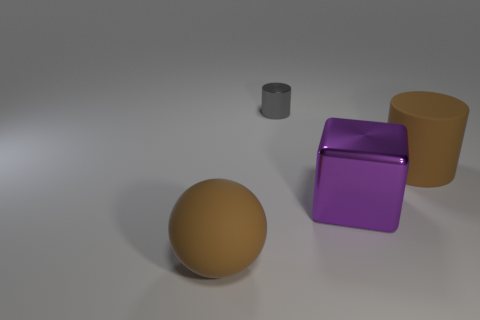Are there any large objects that have the same color as the large ball?
Make the answer very short. Yes. How many blocks are either gray metallic objects or big matte objects?
Give a very brief answer. 0. Is there a brown matte thing of the same shape as the tiny shiny object?
Make the answer very short. Yes. What number of other objects are the same color as the tiny thing?
Give a very brief answer. 0. Are there fewer gray metallic objects that are left of the brown matte sphere than red metal cylinders?
Offer a terse response. No. What number of tiny brown metallic objects are there?
Give a very brief answer. 0. How many cylinders have the same material as the large brown sphere?
Your answer should be very brief. 1. What number of objects are rubber objects that are behind the large rubber sphere or tiny red metal things?
Offer a terse response. 1. Is the number of rubber things on the left side of the large purple cube less than the number of objects on the right side of the brown sphere?
Make the answer very short. Yes. There is a tiny gray cylinder; are there any purple things on the left side of it?
Ensure brevity in your answer.  No. 